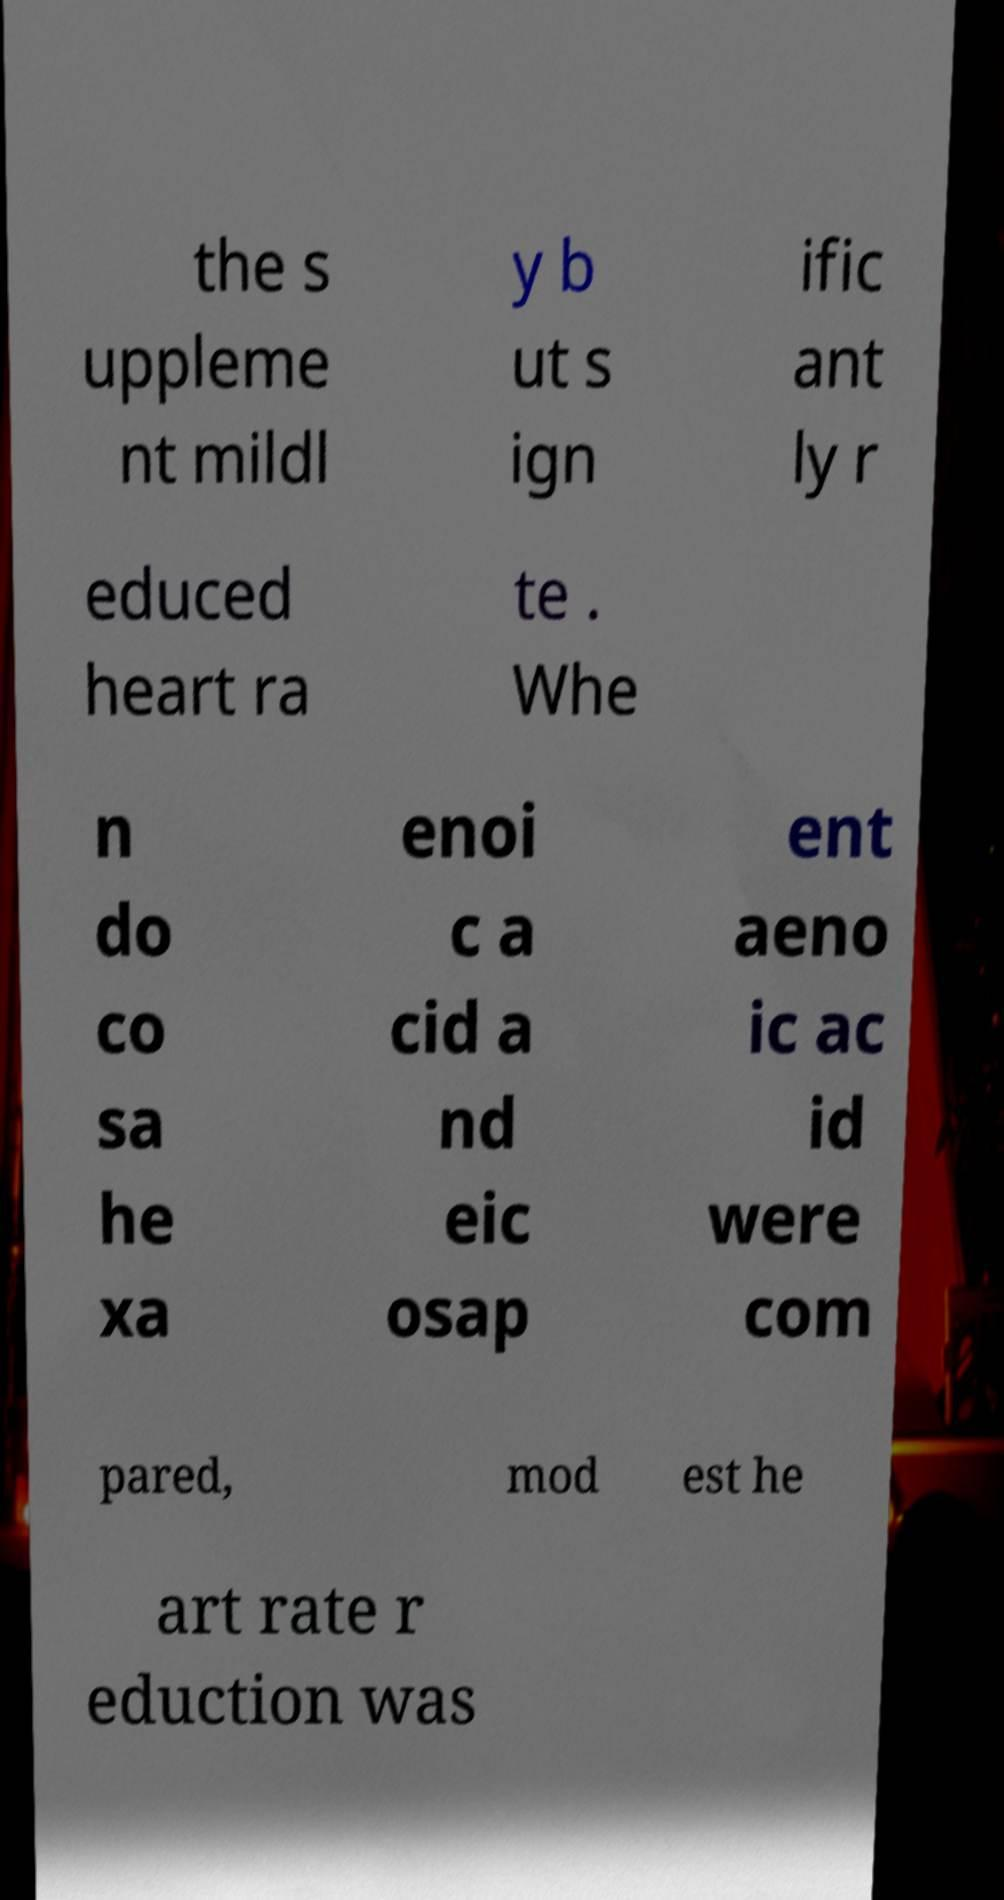For documentation purposes, I need the text within this image transcribed. Could you provide that? the s uppleme nt mildl y b ut s ign ific ant ly r educed heart ra te . Whe n do co sa he xa enoi c a cid a nd eic osap ent aeno ic ac id were com pared, mod est he art rate r eduction was 